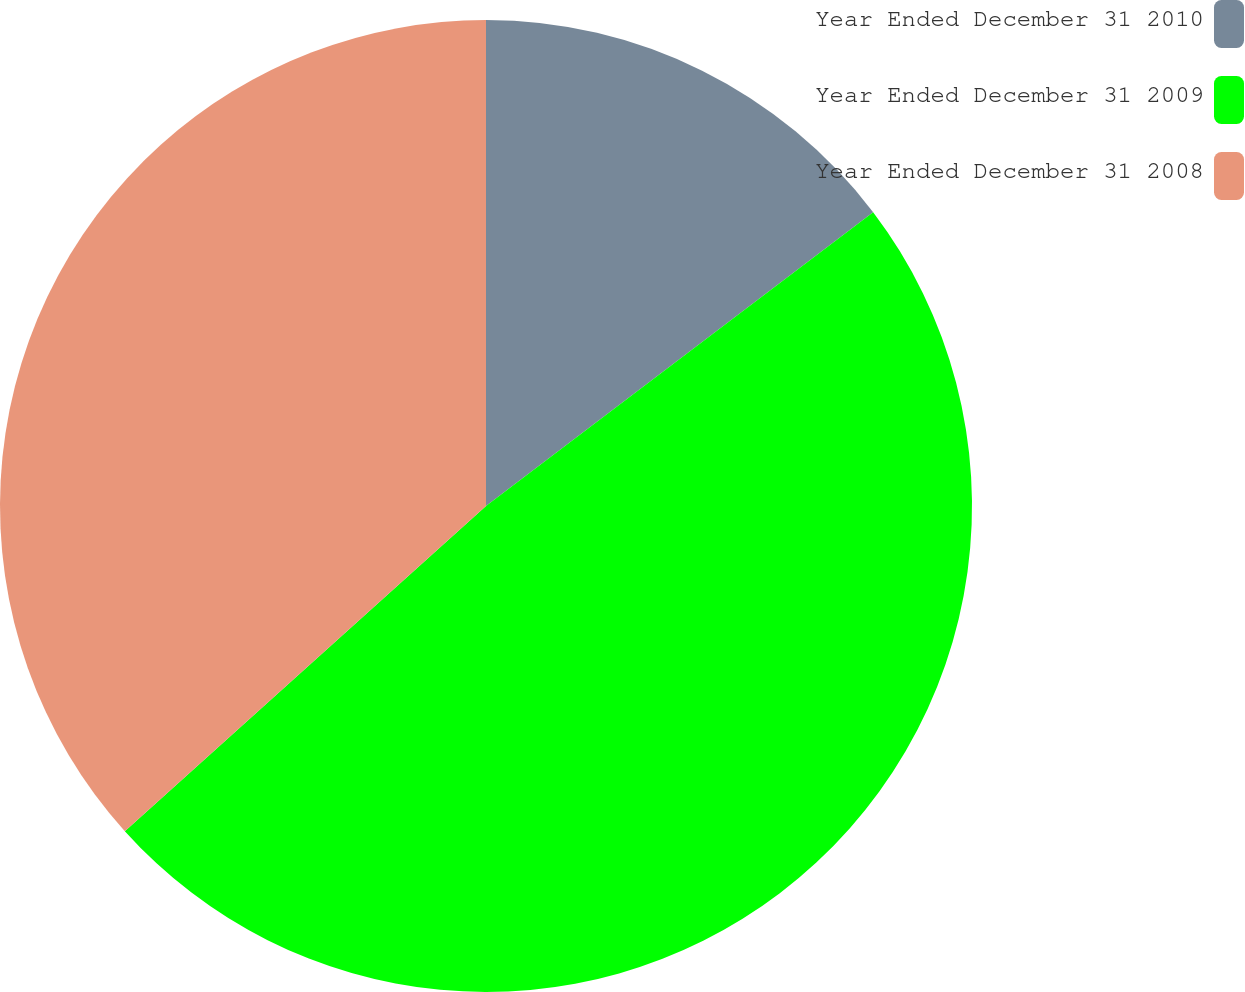Convert chart to OTSL. <chart><loc_0><loc_0><loc_500><loc_500><pie_chart><fcel>Year Ended December 31 2010<fcel>Year Ended December 31 2009<fcel>Year Ended December 31 2008<nl><fcel>14.67%<fcel>48.67%<fcel>36.67%<nl></chart> 